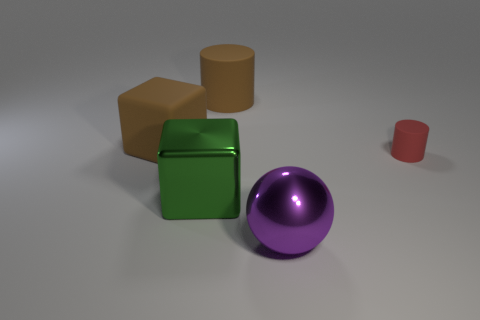What might be the function of these objects if they were part of a larger machine? If these objects were components of a larger machine, we could imagine several functions for them. The green cube might be a weight or a structural support due to its solid build. The purple sphere could serve as a pivot or bearing, allowing parts of the machine to rotate smoothly. The brown cube might act as a counterweight or be part of a locking mechanism. The tan cylinder, with its height, could be a stand or a spacer between layers. And the small red cylinder might be a button or a small roller for light movements or adjustments. 